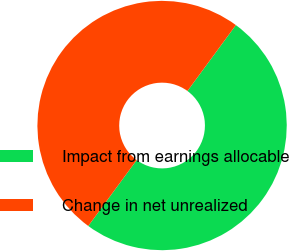<chart> <loc_0><loc_0><loc_500><loc_500><pie_chart><fcel>Impact from earnings allocable<fcel>Change in net unrealized<nl><fcel>50.0%<fcel>50.0%<nl></chart> 